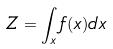<formula> <loc_0><loc_0><loc_500><loc_500>Z = \int _ { x } f ( x ) d x</formula> 